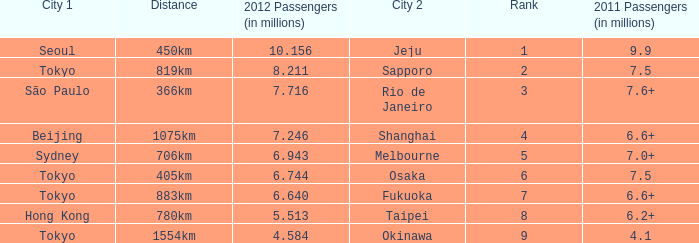How many passengers (in millions) flew from Seoul in 2012? 10.156. 